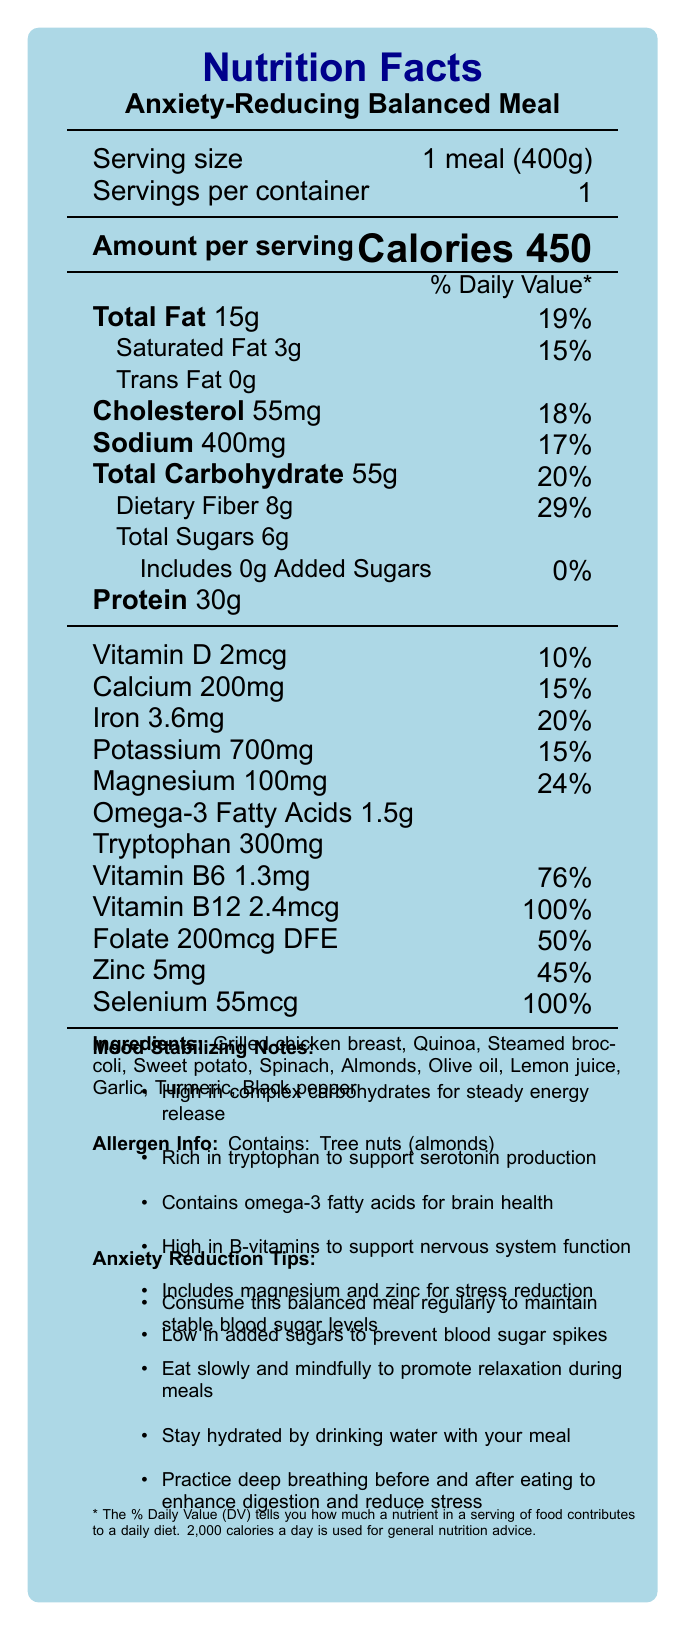what is the serving size for the meal? The serving size is mentioned at the top of the document as "Serving size: 1 meal (400g)".
Answer: 1 meal (400g) What is the total daily value percentage for fiber? The document states that dietary fiber has an 8g amount and a 29% daily value.
Answer: 29% How many calories are in one serving of this meal? Under "Amount per serving," the document lists "Calories 450".
Answer: 450 calories Does the meal contain any trans fats? The document states "Trans Fat 0g", indicating there are no trans fats present.
Answer: No which nutrient has the highest percent daily value? Selenium's daily value is listed at 100%, higher than any other listed nutrient.
Answer: Selenium What are the ingredients of this meal? The ingredient list is provided towards the end of the document.
Answer: Grilled chicken breast, Quinoa, Steamed broccoli, Sweet potato, Spinach, Almonds, Olive oil, Lemon juice, Garlic, Turmeric, Black pepper How much protein is in the meal? The amount of protein is listed as 30g under the "Protein" section.
Answer: 30g What percentage of the daily value of calcium does this meal provide? A. 15% B. 20% C. 18% D. 24% The document states that calcium is provided at 200mg, which is 15% of the daily value.
Answer: A. 15% Which of the following components is not included in the document? I. Omega-3 Fatty Acids II. Omega-6 Fatty Acids III. Zinc The document lists Omega-3 Fatty Acids and Zinc, but it does not mention Omega-6 Fatty Acids.
Answer: Omega-6 Fatty Acids Does this meal contain added sugars? The document states "Includes 0g Added Sugars" with a daily value of 0%.
Answer: No Summarize the document. The summary encompasses the main nutritional components, mood-stabilizing properties, ingredients, allergen information, and additional tips provided in the document.
Answer: The document provides detailed nutritional information for a balanced meal that aims to stabilize mood and reduce anxiety. It includes the serving size, calories, and daily values for various nutrients. The ingredients are natural and the meal is designed to support brain health and reduce stress through the inclusion of nutrients like tryptophan, omega-3 fatty acids, B-vitamins, and minerals like magnesium and zinc. It also offers tips for anxiety reduction through mindful eating and staying hydrated. Allergens such as tree nuts (almonds) are also identified. Does the document specify how much vitamin A is in the meal? The document does not list any information regarding the amount of vitamin A.
Answer: Not enough information 